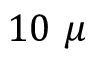<formula> <loc_0><loc_0><loc_500><loc_500>1 0 \mu</formula> 